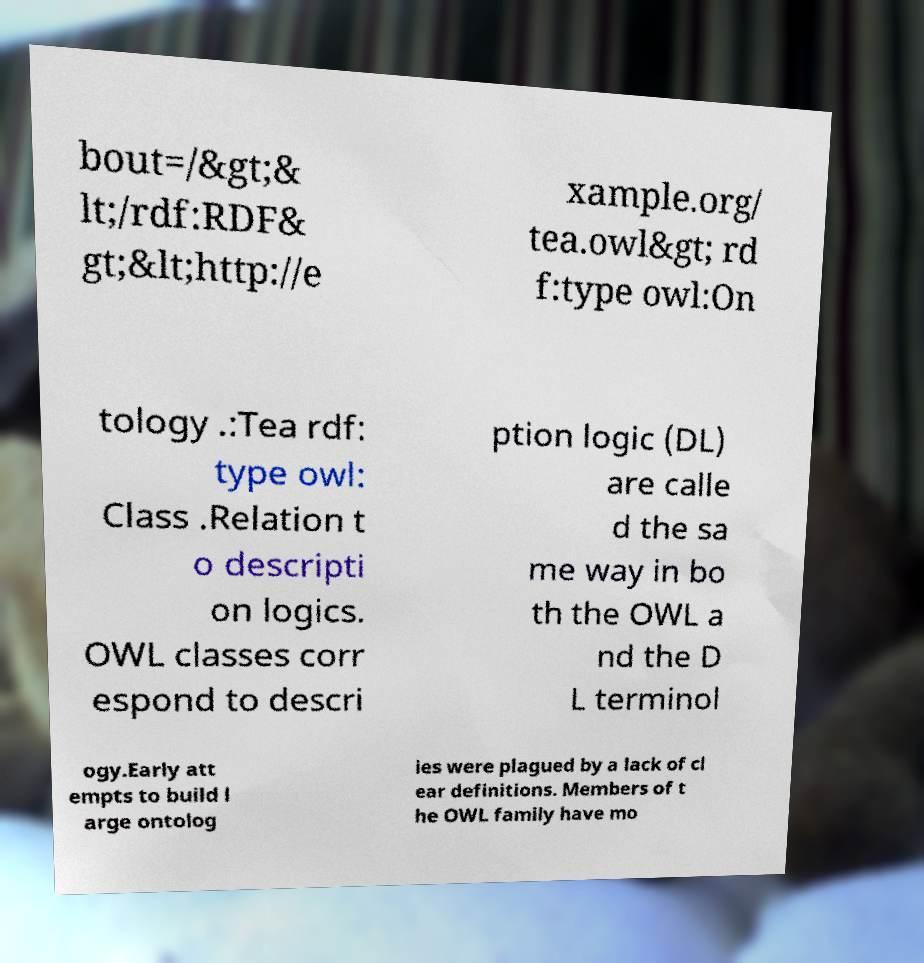Please read and relay the text visible in this image. What does it say? bout=/&gt;& lt;/rdf:RDF& gt;&lt;http://e xample.org/ tea.owl&gt; rd f:type owl:On tology .:Tea rdf: type owl: Class .Relation t o descripti on logics. OWL classes corr espond to descri ption logic (DL) are calle d the sa me way in bo th the OWL a nd the D L terminol ogy.Early att empts to build l arge ontolog ies were plagued by a lack of cl ear definitions. Members of t he OWL family have mo 